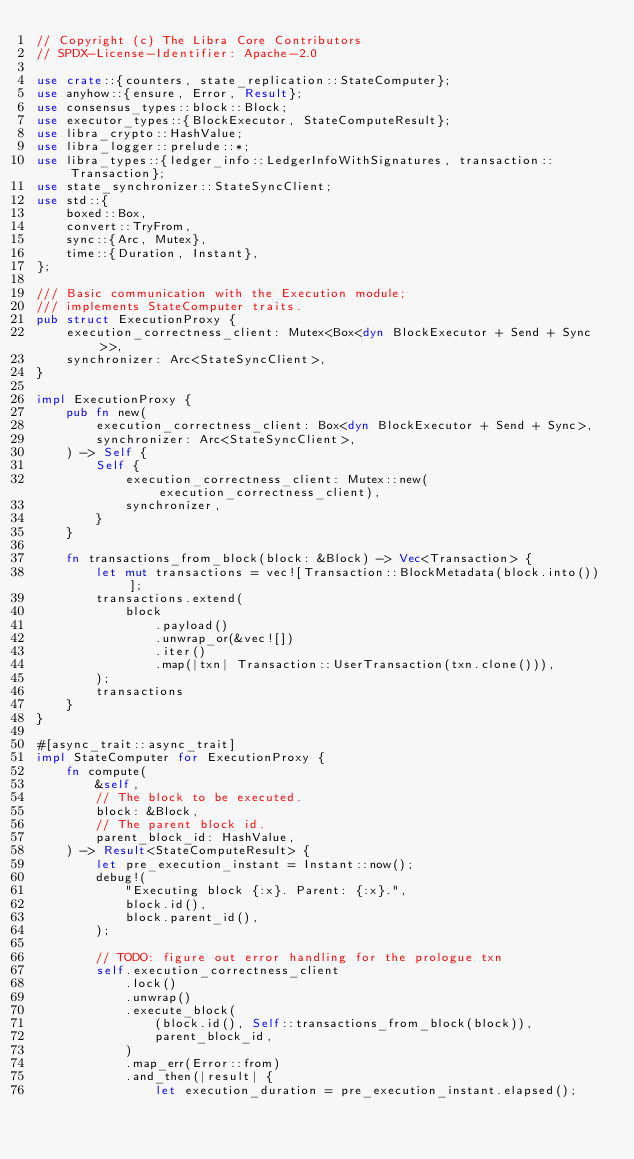<code> <loc_0><loc_0><loc_500><loc_500><_Rust_>// Copyright (c) The Libra Core Contributors
// SPDX-License-Identifier: Apache-2.0

use crate::{counters, state_replication::StateComputer};
use anyhow::{ensure, Error, Result};
use consensus_types::block::Block;
use executor_types::{BlockExecutor, StateComputeResult};
use libra_crypto::HashValue;
use libra_logger::prelude::*;
use libra_types::{ledger_info::LedgerInfoWithSignatures, transaction::Transaction};
use state_synchronizer::StateSyncClient;
use std::{
    boxed::Box,
    convert::TryFrom,
    sync::{Arc, Mutex},
    time::{Duration, Instant},
};

/// Basic communication with the Execution module;
/// implements StateComputer traits.
pub struct ExecutionProxy {
    execution_correctness_client: Mutex<Box<dyn BlockExecutor + Send + Sync>>,
    synchronizer: Arc<StateSyncClient>,
}

impl ExecutionProxy {
    pub fn new(
        execution_correctness_client: Box<dyn BlockExecutor + Send + Sync>,
        synchronizer: Arc<StateSyncClient>,
    ) -> Self {
        Self {
            execution_correctness_client: Mutex::new(execution_correctness_client),
            synchronizer,
        }
    }

    fn transactions_from_block(block: &Block) -> Vec<Transaction> {
        let mut transactions = vec![Transaction::BlockMetadata(block.into())];
        transactions.extend(
            block
                .payload()
                .unwrap_or(&vec![])
                .iter()
                .map(|txn| Transaction::UserTransaction(txn.clone())),
        );
        transactions
    }
}

#[async_trait::async_trait]
impl StateComputer for ExecutionProxy {
    fn compute(
        &self,
        // The block to be executed.
        block: &Block,
        // The parent block id.
        parent_block_id: HashValue,
    ) -> Result<StateComputeResult> {
        let pre_execution_instant = Instant::now();
        debug!(
            "Executing block {:x}. Parent: {:x}.",
            block.id(),
            block.parent_id(),
        );

        // TODO: figure out error handling for the prologue txn
        self.execution_correctness_client
            .lock()
            .unwrap()
            .execute_block(
                (block.id(), Self::transactions_from_block(block)),
                parent_block_id,
            )
            .map_err(Error::from)
            .and_then(|result| {
                let execution_duration = pre_execution_instant.elapsed();</code> 